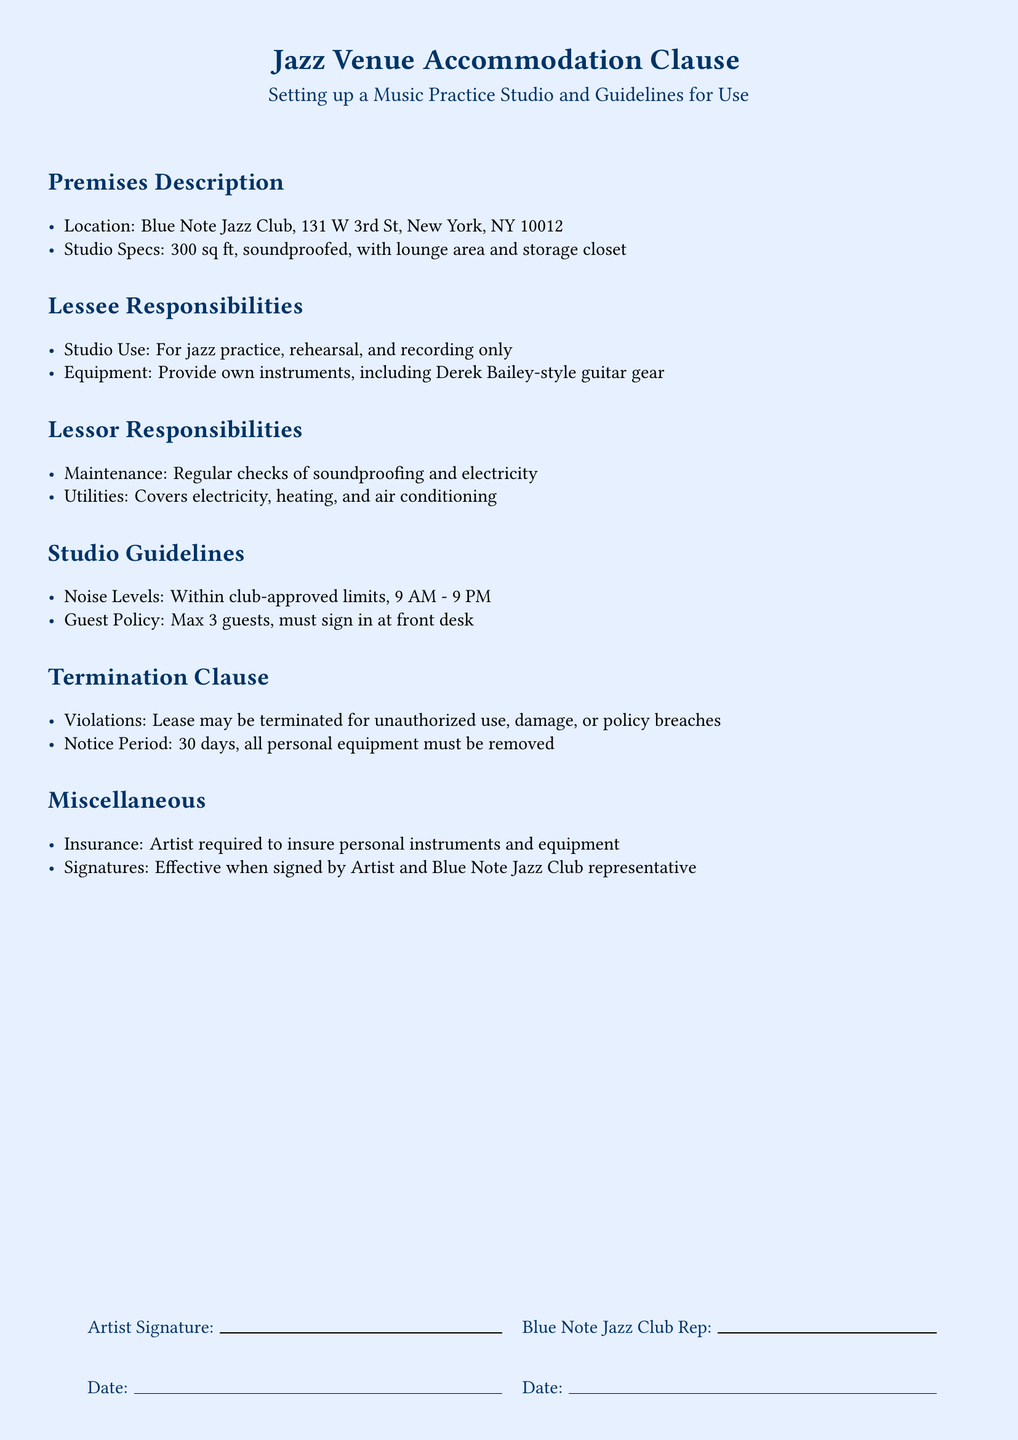What is the location of the studio? The location of the studio is specified in the premises description.
Answer: Blue Note Jazz Club, 131 W 3rd St, New York, NY 10012 What are the dimensions of the studio? The studio specifications detail the size of the studio in square feet.
Answer: 300 sq ft What is the maximum number of guests allowed? The guest policy outlines the limit for guests in the studio.
Answer: Max 3 guests What time are noise levels regulated? The studio guidelines state the approved time for noise levels.
Answer: 9 AM - 9 PM What is the notice period for termination? The termination clause includes the notice period required before lease termination.
Answer: 30 days What type of maintenance is the lessor responsible for? The responsibilities of the lessor include specific maintenance tasks.
Answer: Regular checks of soundproofing and electricity What type of insurance must the artist have? The miscellaneous section specifies what the artist needs to insure.
Answer: Personal instruments and equipment What activities are permitted in the studio? The lessee responsibilities define the acceptable uses of the studio.
Answer: Jazz practice, rehearsal, and recording only What style of guitar gear must the artist provide? The lessee responsibilities indicate the specific type of gear required.
Answer: Derek Bailey-style guitar gear 